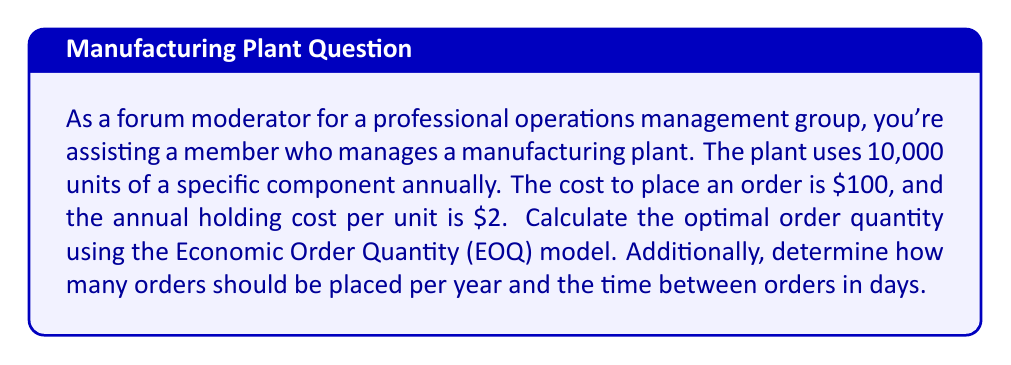Provide a solution to this math problem. To solve this problem, we'll use the Economic Order Quantity (EOQ) model. The EOQ formula is:

$$ EOQ = \sqrt{\frac{2DS}{H}} $$

Where:
$D$ = Annual demand
$S$ = Setup (ordering) cost per order
$H$ = Holding cost per unit per year

Given:
$D = 10,000$ units
$S = \$100$ per order
$H = \$2$ per unit per year

Step 1: Calculate the EOQ
$$ EOQ = \sqrt{\frac{2 \times 10,000 \times 100}{2}} = \sqrt{1,000,000} = 1,000 \text{ units} $$

Step 2: Calculate the number of orders per year
$$ \text{Number of orders} = \frac{\text{Annual demand}}{\text{EOQ}} = \frac{10,000}{1,000} = 10 \text{ orders per year} $$

Step 3: Calculate the time between orders
$$ \text{Time between orders} = \frac{\text{Number of working days in a year}}{\text{Number of orders}} $$

Assuming 250 working days in a year:
$$ \text{Time between orders} = \frac{250}{10} = 25 \text{ days} $$
Answer: Optimal order quantity (EOQ): 1,000 units
Number of orders per year: 10
Time between orders: 25 days 